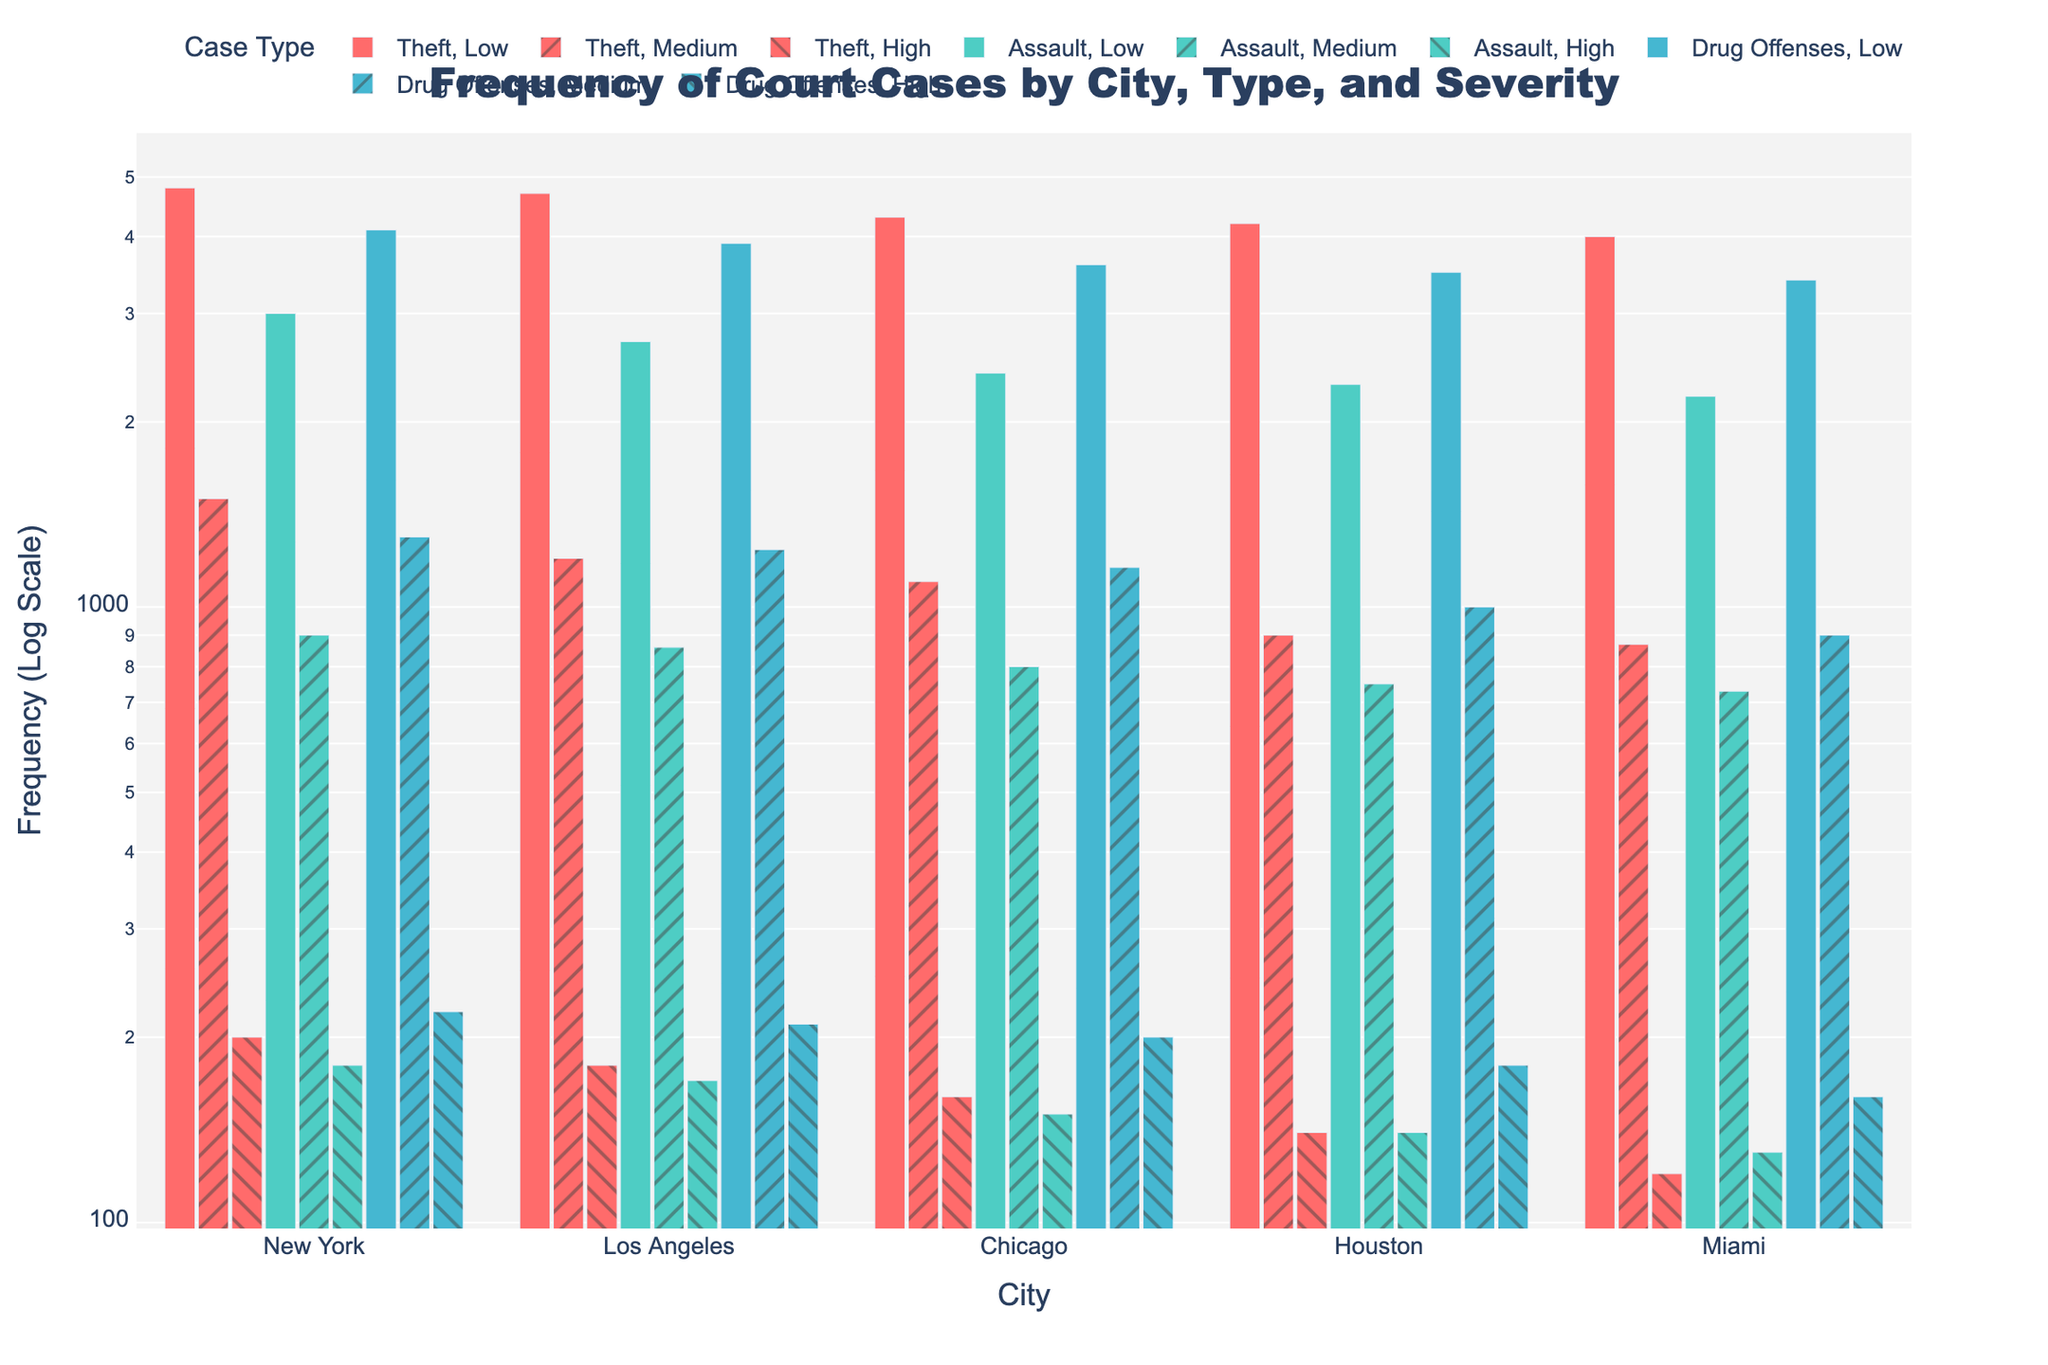What's the title of this figure? The title is displayed at the top of the figure and usually gives an overview of what the chart represents. Here, it reads "Frequency of Court Cases by City, Type, and Severity".
Answer: Frequency of Court Cases by City, Type, and Severity What's the highest frequency of Theft cases in New York by severity? Look at the Theft cases in New York and compare the frequencies for High, Medium, and Low severity. The highest frequency is for Low severity.
Answer: Low Which city has the least frequency of High severity Theft cases? Compare the frequencies of High severity Theft cases across all cities. The city with the least frequency is Miami.
Answer: Miami What is the order of cities based on the frequency of Medium severity Drug Offenses from highest to lowest? Look at the frequencies for Medium severity Drug Offenses in each city and order them. The order is: New York, Los Angeles, Chicago, Houston, Miami.
Answer: New York, Los Angeles, Chicago, Houston, Miami How does the frequency of Low severity Assault cases in New York compare to Los Angeles? Compare the frequency bars of Low severity Assault cases in New York and Los Angeles. New York has a higher frequency than Los Angeles.
Answer: Higher Which city has the most balanced frequencies between the three severities for Drug Offenses? Look at the frequencies for Drug Offenses in each city and compare how close the values for High, Medium, and Low severities are to each other. Chicago appears to have the most balanced frequencies.
Answer: Chicago What is the total frequency of all types of cases (Theft, Assault, Drug Offenses) in Houston for all severities? Add up the frequencies for Theft, Assault, and Drug Offenses in Houston across all severities: 140+900+4200+140+750+2300+180+1000+3500 = 14010.
Answer: 14010 Which case type shows the highest frequency across all cities combined? Compare the total frequencies for Thefts, Assaults, and Drug Offenses across all cities. Theft has the highest combined frequency.
Answer: Theft Does New York have a higher frequency of Medium severity cases for Theft or Drug Offenses? Compare the frequency bars for Medium severity Theft and Drug Offenses in New York. Drug Offenses have a higher frequency than Theft.
Answer: Drug Offenses How does the severity distribution of Assault cases vary between Miami and Chicago? Look at the frequency distribution for Assault cases based on severity in Miami and Chicago. Miami and Chicago both show decreasing frequencies from Low to High, but specific frequencies differ.
Answer: Decreasing 